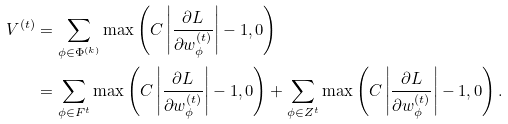<formula> <loc_0><loc_0><loc_500><loc_500>V ^ { ( t ) } & = \sum _ { \phi \in \Phi ^ { ( k ) } } \max \left ( C \left | \frac { \partial L } { \partial w _ { \phi } ^ { ( t ) } } \right | - 1 , 0 \right ) \\ & = \sum _ { \phi \in F ^ { t } } \max \left ( C \left | \frac { \partial L } { \partial w _ { \phi } ^ { ( t ) } } \right | - 1 , 0 \right ) + \sum _ { \phi \in Z ^ { t } } \max \left ( C \left | \frac { \partial L } { \partial w _ { \phi } ^ { ( t ) } } \right | - 1 , 0 \right ) .</formula> 